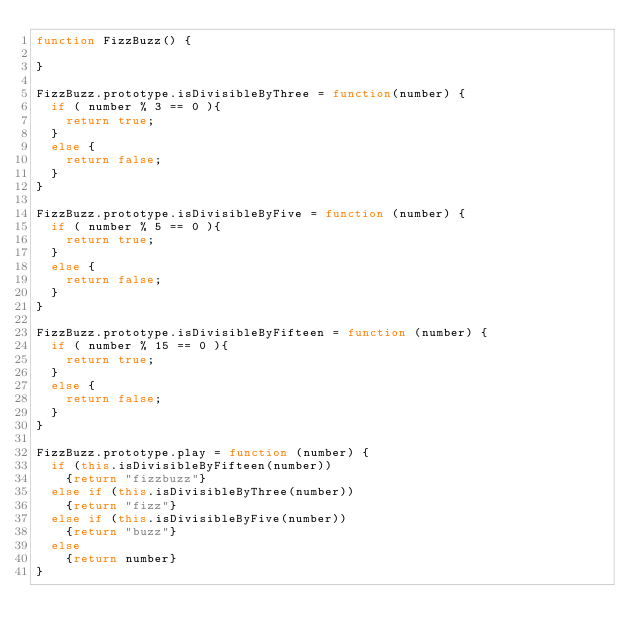Convert code to text. <code><loc_0><loc_0><loc_500><loc_500><_JavaScript_>function FizzBuzz() {

}

FizzBuzz.prototype.isDivisibleByThree = function(number) {
  if ( number % 3 == 0 ){
    return true;
  }
  else {
    return false;
  }
}

FizzBuzz.prototype.isDivisibleByFive = function (number) {
  if ( number % 5 == 0 ){
    return true;
  }
  else {
    return false;
  }
}

FizzBuzz.prototype.isDivisibleByFifteen = function (number) {
  if ( number % 15 == 0 ){
    return true;
  }
  else {
    return false;
  }
}

FizzBuzz.prototype.play = function (number) {
  if (this.isDivisibleByFifteen(number))
    {return "fizzbuzz"}
  else if (this.isDivisibleByThree(number))
    {return "fizz"}
  else if (this.isDivisibleByFive(number))
    {return "buzz"}
  else
    {return number}
}
</code> 